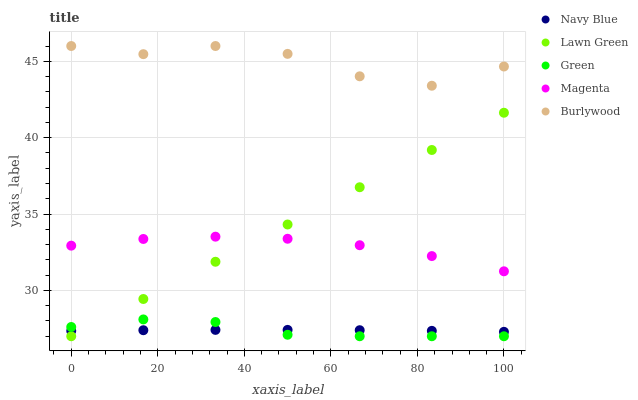Does Navy Blue have the minimum area under the curve?
Answer yes or no. Yes. Does Burlywood have the maximum area under the curve?
Answer yes or no. Yes. Does Magenta have the minimum area under the curve?
Answer yes or no. No. Does Magenta have the maximum area under the curve?
Answer yes or no. No. Is Lawn Green the smoothest?
Answer yes or no. Yes. Is Burlywood the roughest?
Answer yes or no. Yes. Is Navy Blue the smoothest?
Answer yes or no. No. Is Navy Blue the roughest?
Answer yes or no. No. Does Green have the lowest value?
Answer yes or no. Yes. Does Navy Blue have the lowest value?
Answer yes or no. No. Does Burlywood have the highest value?
Answer yes or no. Yes. Does Magenta have the highest value?
Answer yes or no. No. Is Magenta less than Burlywood?
Answer yes or no. Yes. Is Burlywood greater than Lawn Green?
Answer yes or no. Yes. Does Lawn Green intersect Green?
Answer yes or no. Yes. Is Lawn Green less than Green?
Answer yes or no. No. Is Lawn Green greater than Green?
Answer yes or no. No. Does Magenta intersect Burlywood?
Answer yes or no. No. 